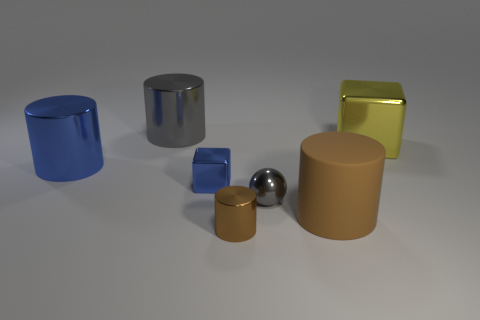Add 1 small gray spheres. How many objects exist? 8 Subtract all cubes. How many objects are left? 5 Add 3 large blue cylinders. How many large blue cylinders are left? 4 Add 5 large gray metallic cylinders. How many large gray metallic cylinders exist? 6 Subtract 0 yellow balls. How many objects are left? 7 Subtract all big cyan metal cylinders. Subtract all large gray cylinders. How many objects are left? 6 